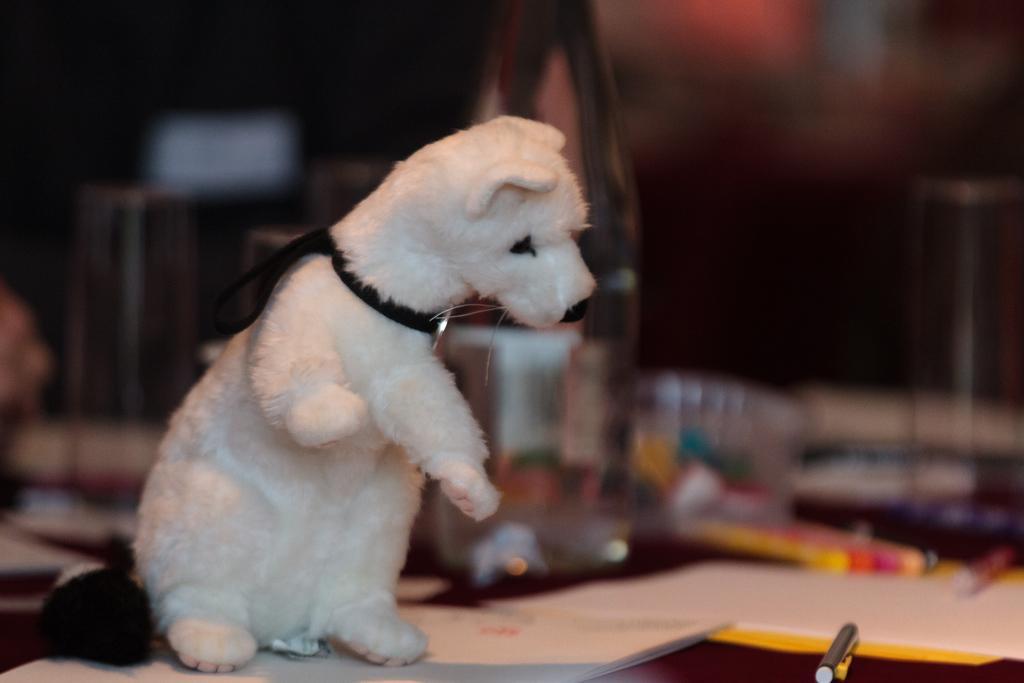In one or two sentences, can you explain what this image depicts? In this picture, we see a dog in white color. We see a pen and papers are placed on the table. In the background, we see some elements which are blurred. 